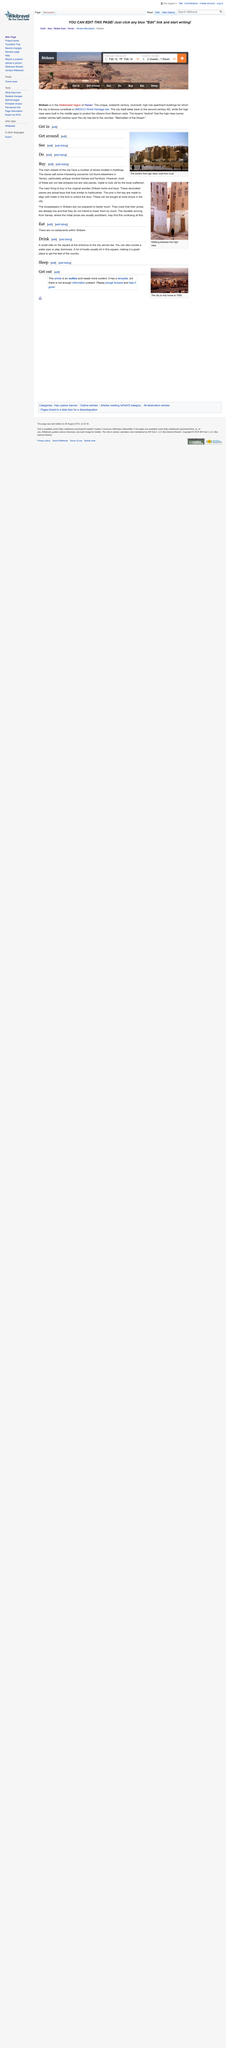Point out several critical features in this image. Shimbam, located in Yemen, is part of the Hadramawt region. The city of Shibam in Yemen dates back to the second century AD. The check-in date on the photograph is February 12th. 